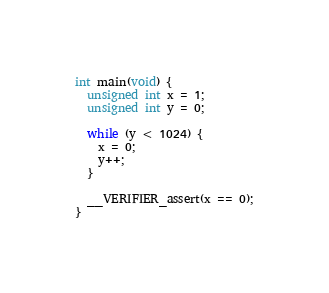<code> <loc_0><loc_0><loc_500><loc_500><_C_>int main(void) {
  unsigned int x = 1;
  unsigned int y = 0;

  while (y < 1024) {
    x = 0;
    y++;
  }

  __VERIFIER_assert(x == 0);
}
</code> 